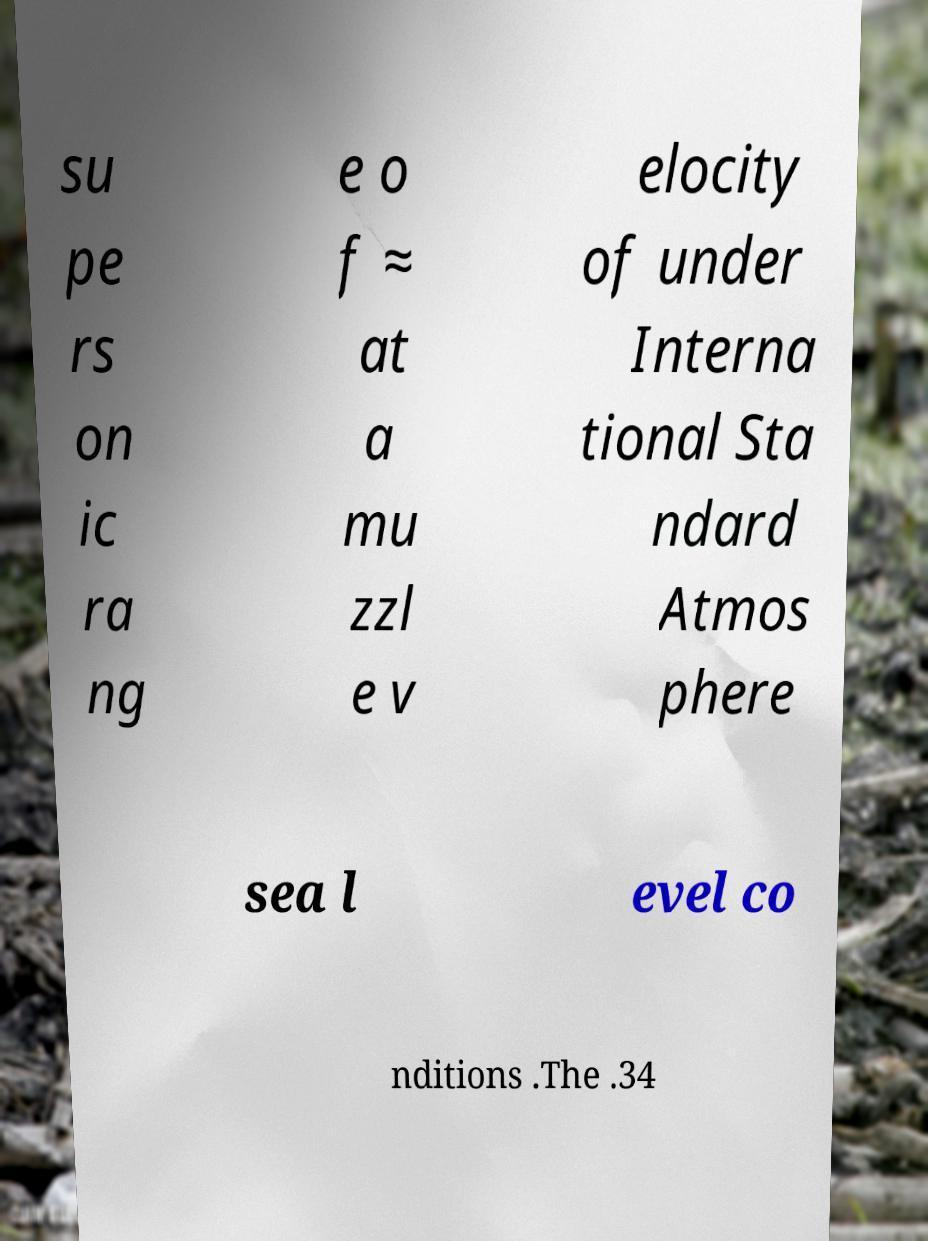Could you assist in decoding the text presented in this image and type it out clearly? su pe rs on ic ra ng e o f ≈ at a mu zzl e v elocity of under Interna tional Sta ndard Atmos phere sea l evel co nditions .The .34 